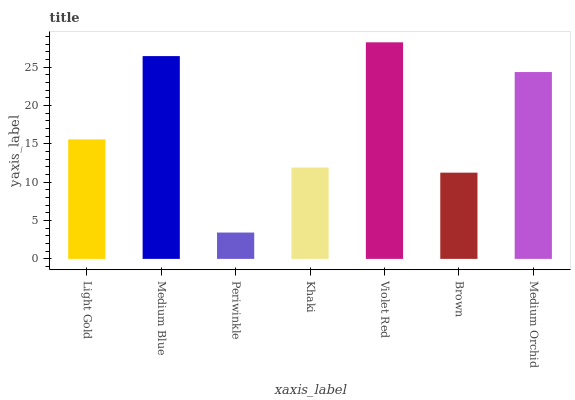Is Periwinkle the minimum?
Answer yes or no. Yes. Is Violet Red the maximum?
Answer yes or no. Yes. Is Medium Blue the minimum?
Answer yes or no. No. Is Medium Blue the maximum?
Answer yes or no. No. Is Medium Blue greater than Light Gold?
Answer yes or no. Yes. Is Light Gold less than Medium Blue?
Answer yes or no. Yes. Is Light Gold greater than Medium Blue?
Answer yes or no. No. Is Medium Blue less than Light Gold?
Answer yes or no. No. Is Light Gold the high median?
Answer yes or no. Yes. Is Light Gold the low median?
Answer yes or no. Yes. Is Medium Orchid the high median?
Answer yes or no. No. Is Medium Blue the low median?
Answer yes or no. No. 